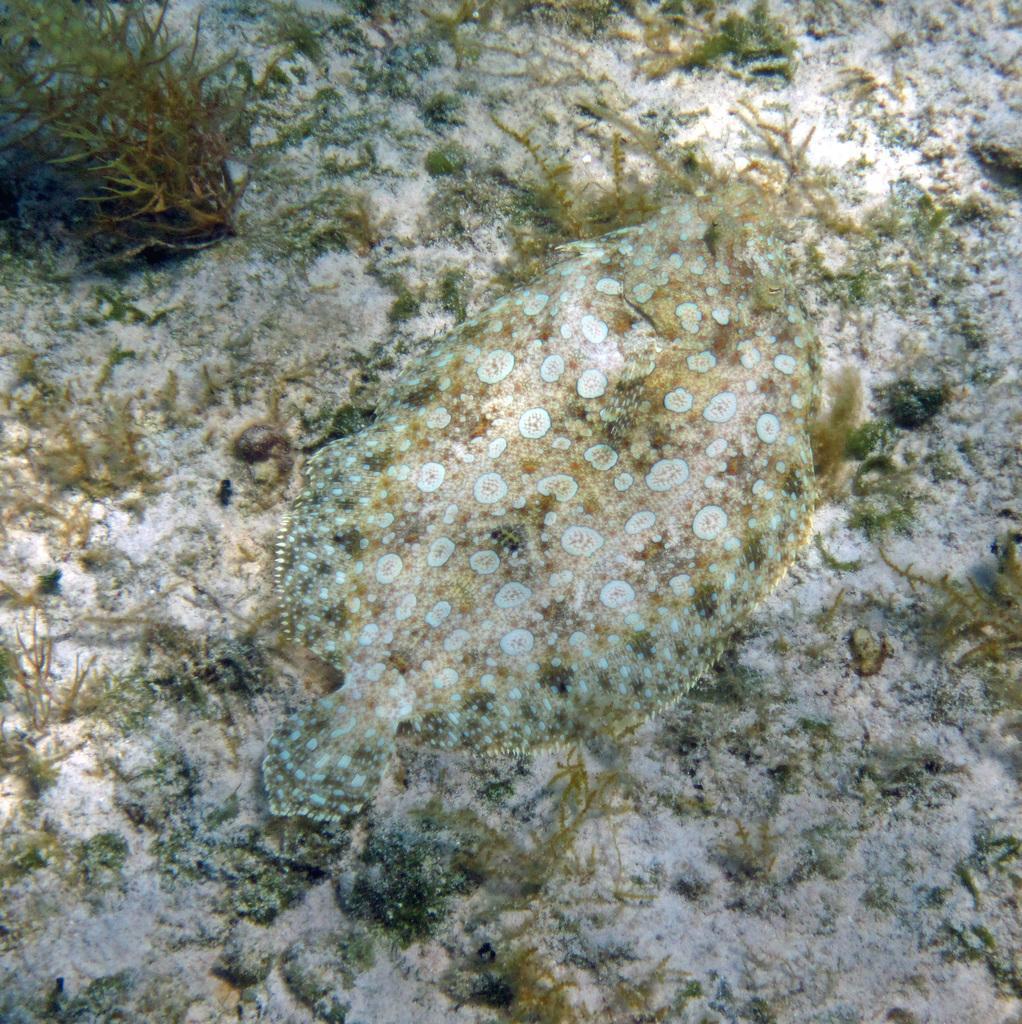Can you describe this image briefly? Here we can see a sea animal and plants. 